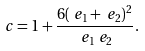<formula> <loc_0><loc_0><loc_500><loc_500>c & = 1 + \frac { 6 ( \ e _ { 1 } + \ e _ { 2 } ) ^ { 2 } } { \ e _ { 1 } \ e _ { 2 } } .</formula> 